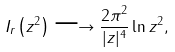<formula> <loc_0><loc_0><loc_500><loc_500>I _ { r } \left ( z ^ { 2 } \right ) \longrightarrow \frac { 2 \pi ^ { 2 } } { | z | ^ { 4 } } \ln z ^ { 2 } ,</formula> 